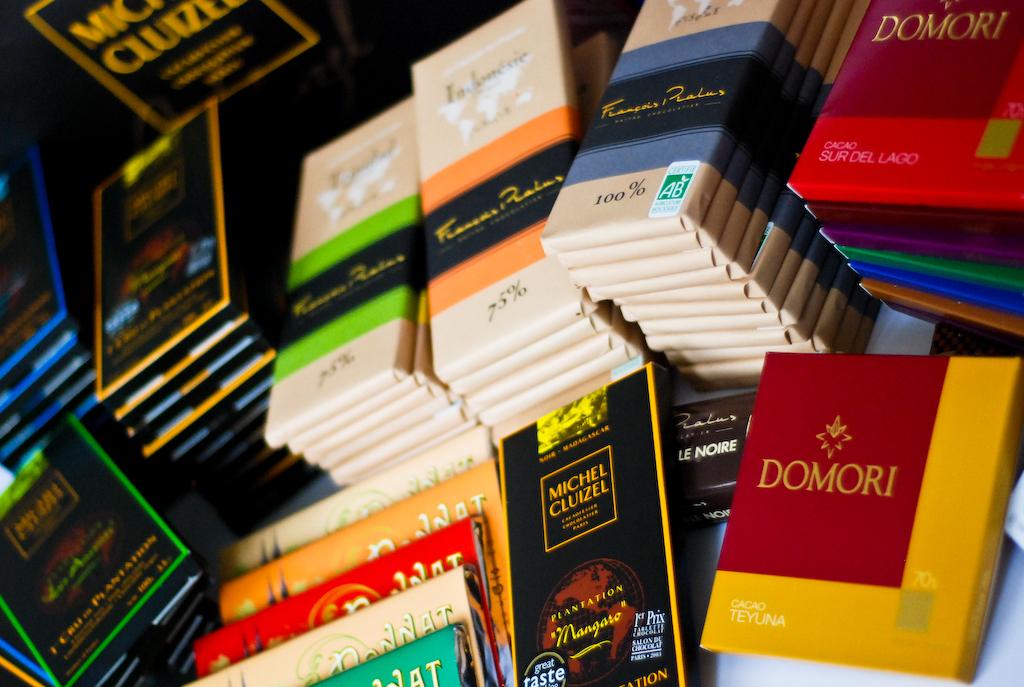What is written in the red box in the bottom right?
Offer a terse response. Domori. 